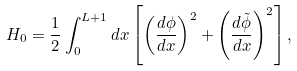Convert formula to latex. <formula><loc_0><loc_0><loc_500><loc_500>H _ { 0 } = \frac { 1 } { 2 } \int ^ { L + 1 } _ { 0 } d x \left [ \left ( \frac { d \phi } { d x } \right ) ^ { 2 } + \left ( \frac { d \tilde { \phi } } { d x } \right ) ^ { 2 } \right ] ,</formula> 